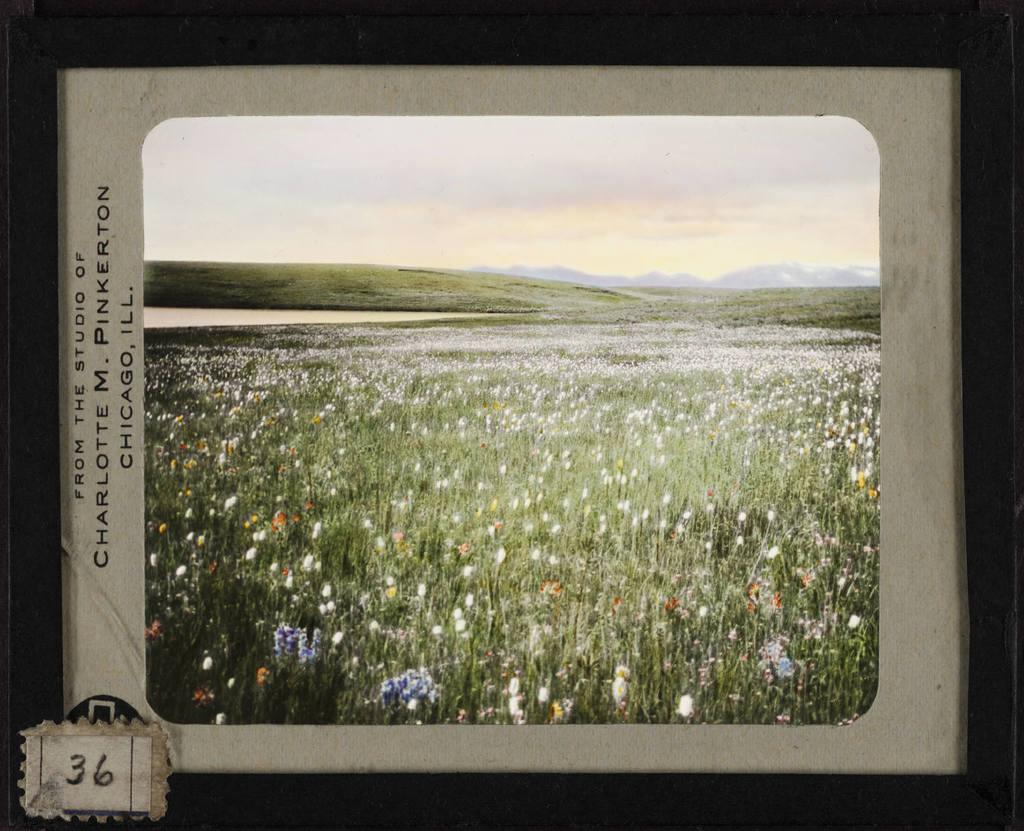<image>
Give a short and clear explanation of the subsequent image. A painting of a field filled with flowers from the Studio of Charlotte M. Pinkerton. 